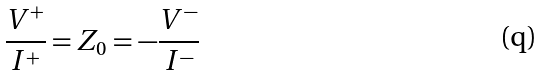<formula> <loc_0><loc_0><loc_500><loc_500>\frac { V ^ { + } } { I ^ { + } } = Z _ { 0 } = - \frac { V ^ { - } } { I ^ { - } }</formula> 